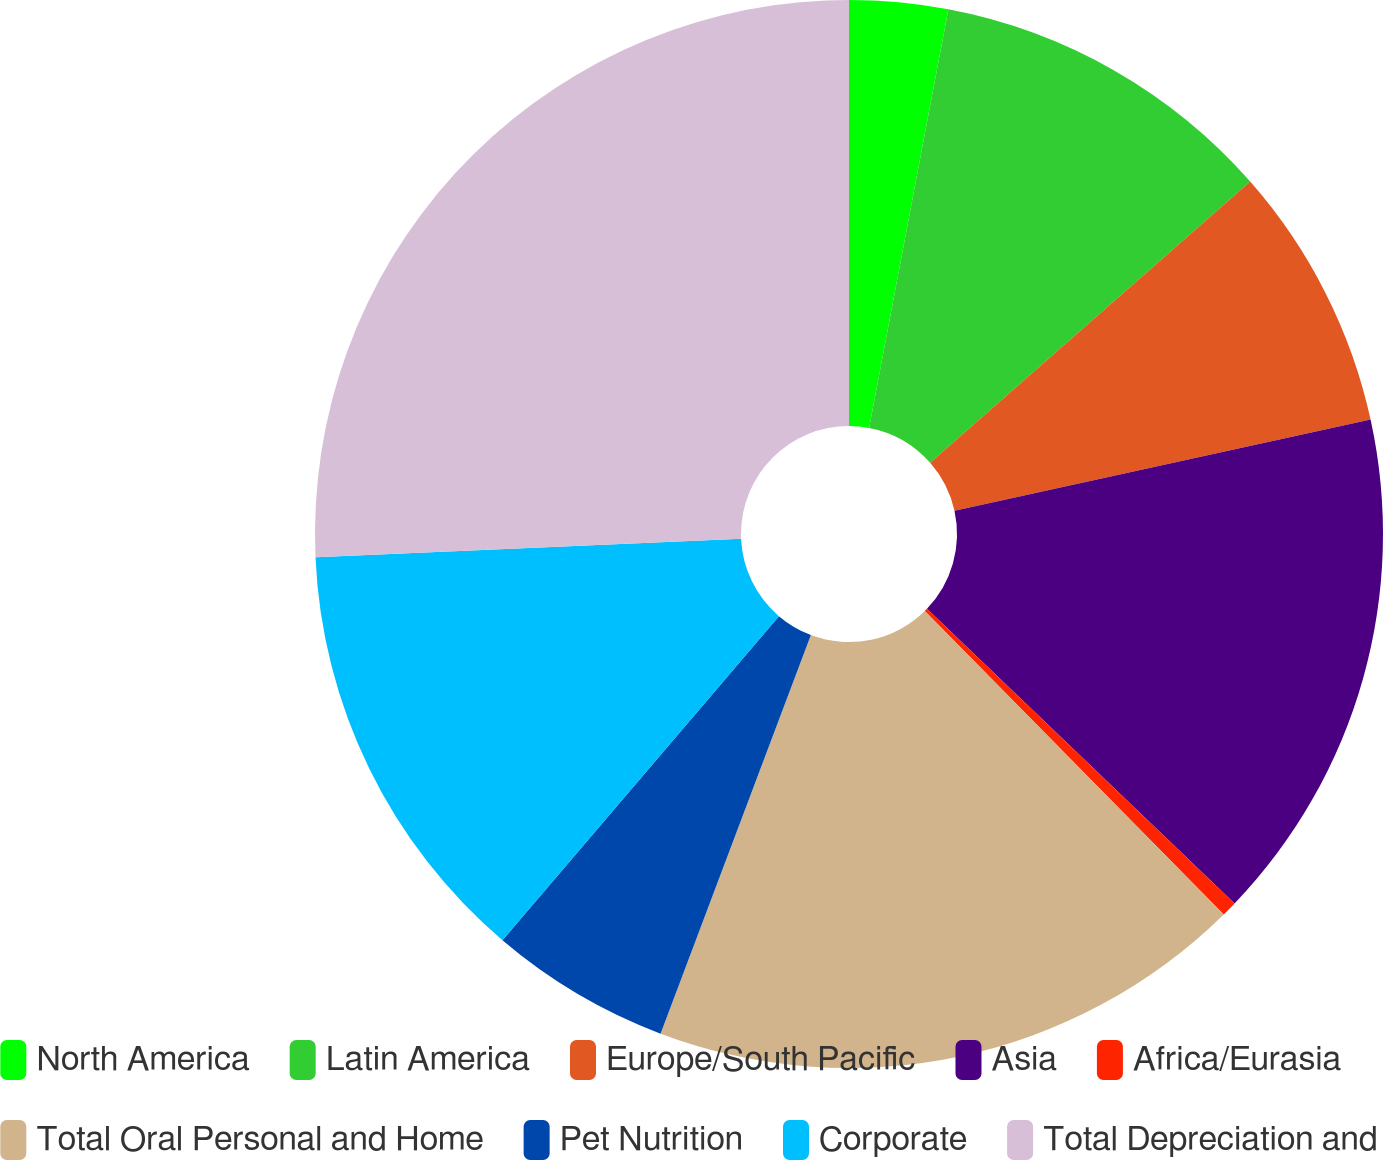Convert chart to OTSL. <chart><loc_0><loc_0><loc_500><loc_500><pie_chart><fcel>North America<fcel>Latin America<fcel>Europe/South Pacific<fcel>Asia<fcel>Africa/Eurasia<fcel>Total Oral Personal and Home<fcel>Pet Nutrition<fcel>Corporate<fcel>Total Depreciation and<nl><fcel>2.98%<fcel>10.55%<fcel>8.03%<fcel>15.6%<fcel>0.46%<fcel>18.12%<fcel>5.5%<fcel>13.07%<fcel>25.69%<nl></chart> 